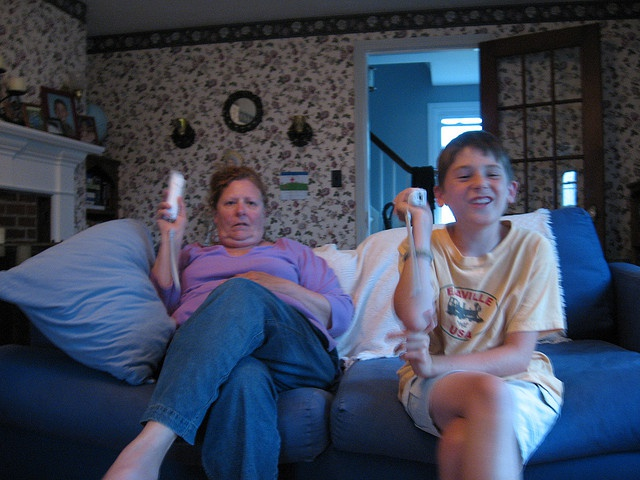Describe the objects in this image and their specific colors. I can see people in black, navy, darkgray, brown, and gray tones, couch in black, navy, blue, and darkblue tones, remote in black, lavender, and darkgray tones, and remote in black, lightblue, and gray tones in this image. 